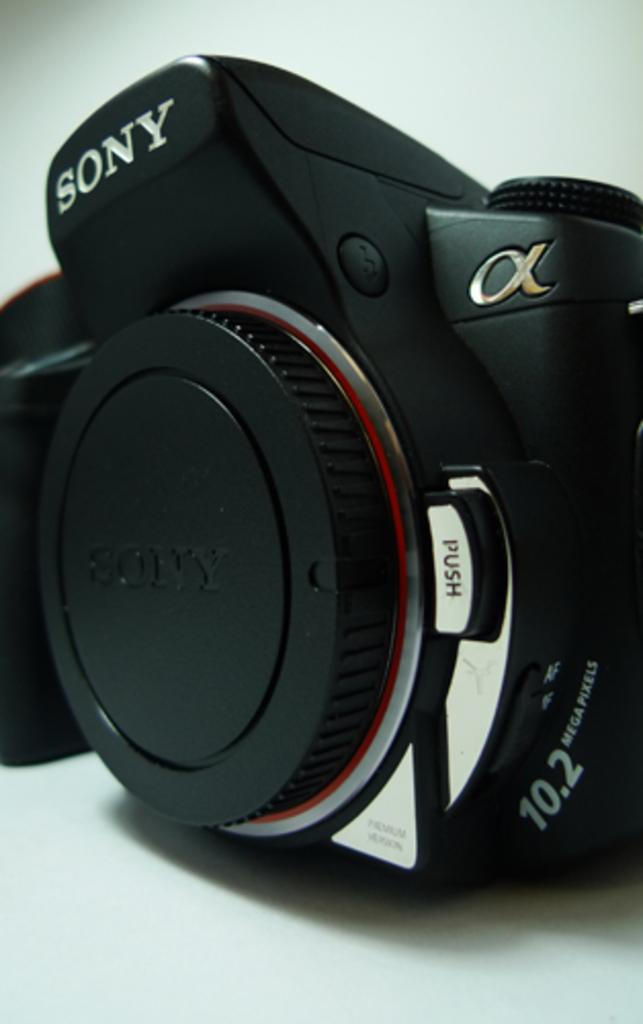What is the main object in the image? There is a camera in the image. What color is the background of the image? The background of the image is white. How many carts are being pulled by the giants in the image? There are no carts or giants present in the image; it only features a camera. 